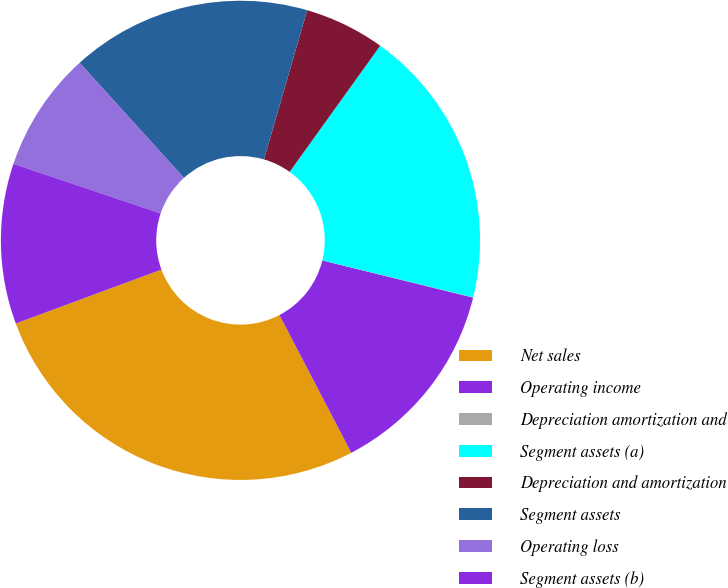Convert chart to OTSL. <chart><loc_0><loc_0><loc_500><loc_500><pie_chart><fcel>Net sales<fcel>Operating income<fcel>Depreciation amortization and<fcel>Segment assets (a)<fcel>Depreciation and amortization<fcel>Segment assets<fcel>Operating loss<fcel>Segment assets (b)<nl><fcel>27.01%<fcel>13.51%<fcel>0.02%<fcel>18.91%<fcel>5.42%<fcel>16.21%<fcel>8.11%<fcel>10.81%<nl></chart> 